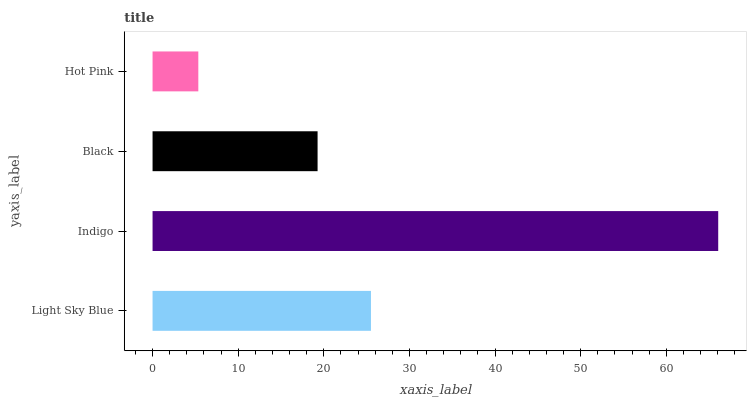Is Hot Pink the minimum?
Answer yes or no. Yes. Is Indigo the maximum?
Answer yes or no. Yes. Is Black the minimum?
Answer yes or no. No. Is Black the maximum?
Answer yes or no. No. Is Indigo greater than Black?
Answer yes or no. Yes. Is Black less than Indigo?
Answer yes or no. Yes. Is Black greater than Indigo?
Answer yes or no. No. Is Indigo less than Black?
Answer yes or no. No. Is Light Sky Blue the high median?
Answer yes or no. Yes. Is Black the low median?
Answer yes or no. Yes. Is Hot Pink the high median?
Answer yes or no. No. Is Light Sky Blue the low median?
Answer yes or no. No. 